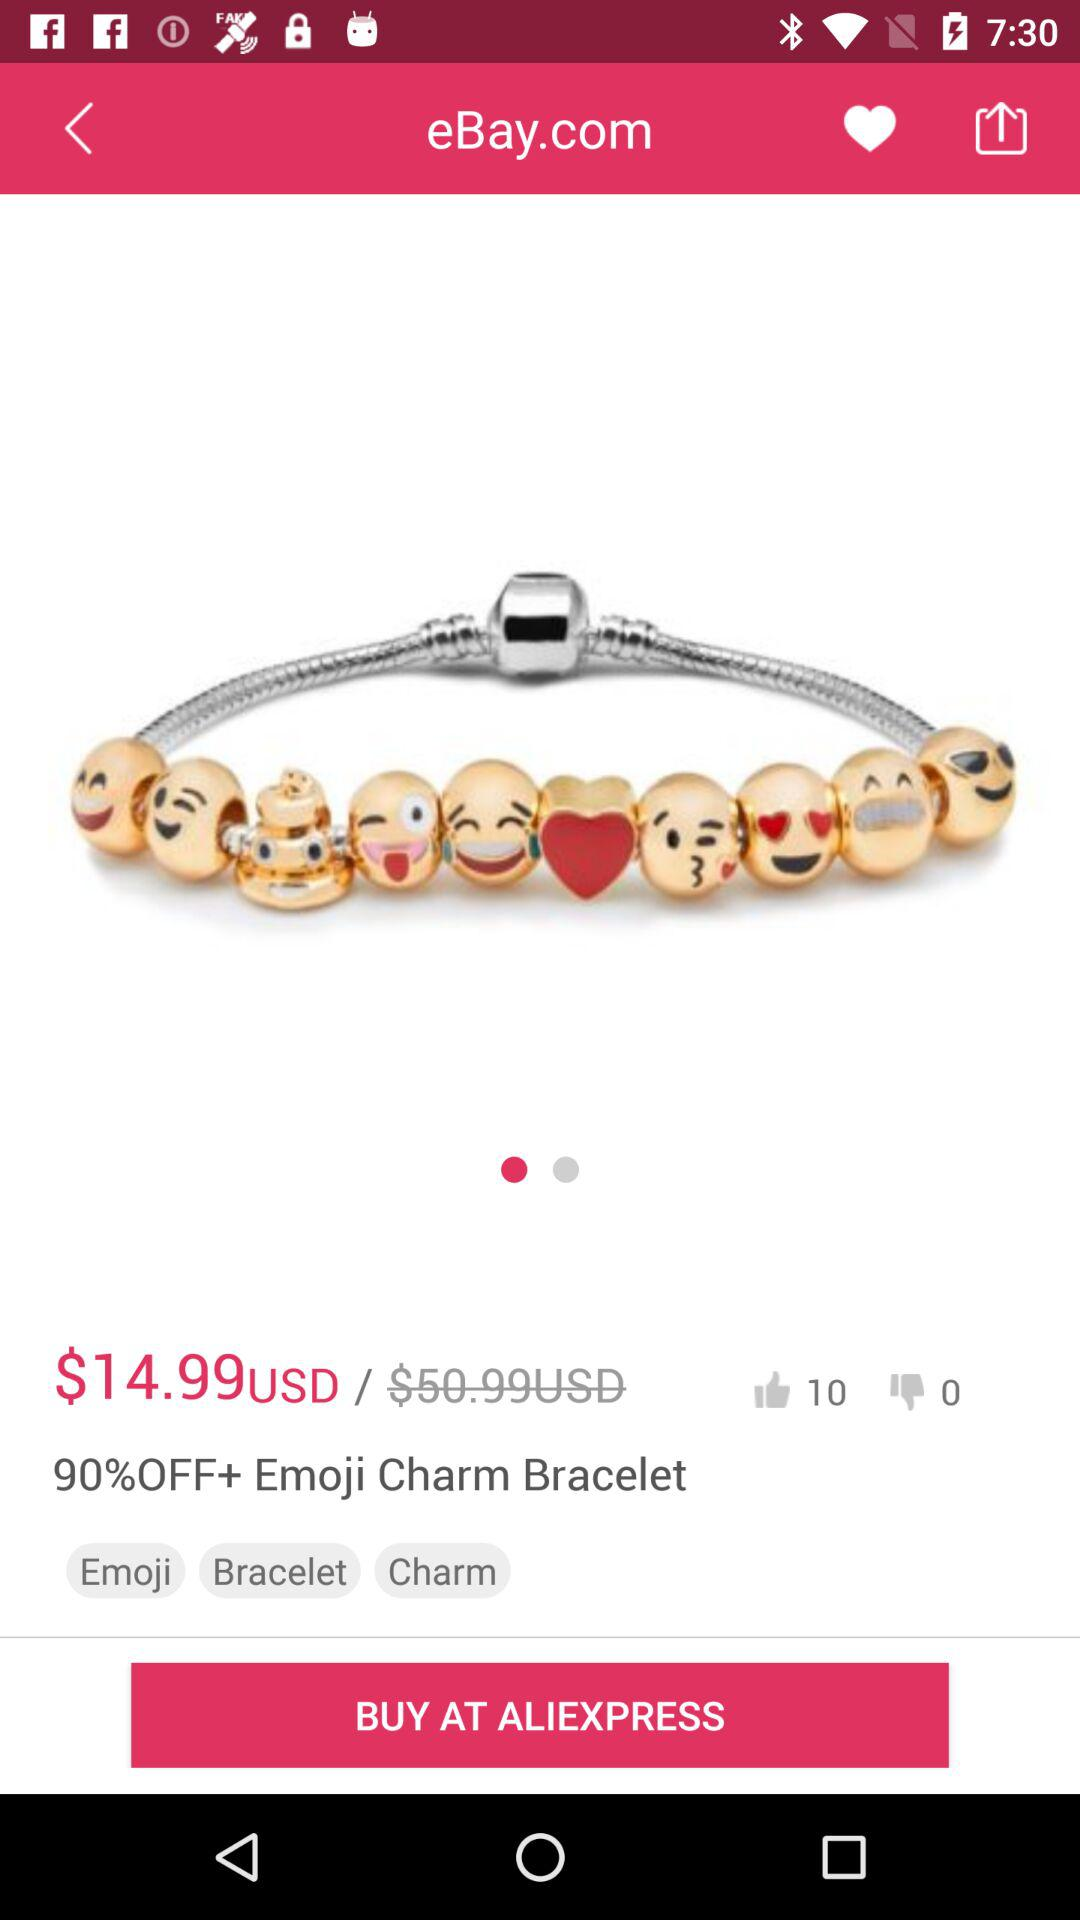What is the percent discount on the "Emoji Charm Bracelet"? The percent discount on the "Emoji Charm Bracelet" is 90. 